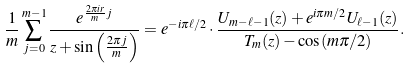Convert formula to latex. <formula><loc_0><loc_0><loc_500><loc_500>\frac { 1 } { m } \sum _ { j = 0 } ^ { m - 1 } \frac { e ^ { \frac { 2 \pi i r } { m } j } } { z + \sin \left ( \frac { 2 \pi j } { m } \right ) } = e ^ { - i \pi \ell / 2 } \cdot \frac { U _ { m - \ell - 1 } ( z ) + e ^ { i \pi m / 2 } U _ { \ell - 1 } ( z ) } { T _ { m } ( z ) - \cos ( m \pi / 2 ) } .</formula> 